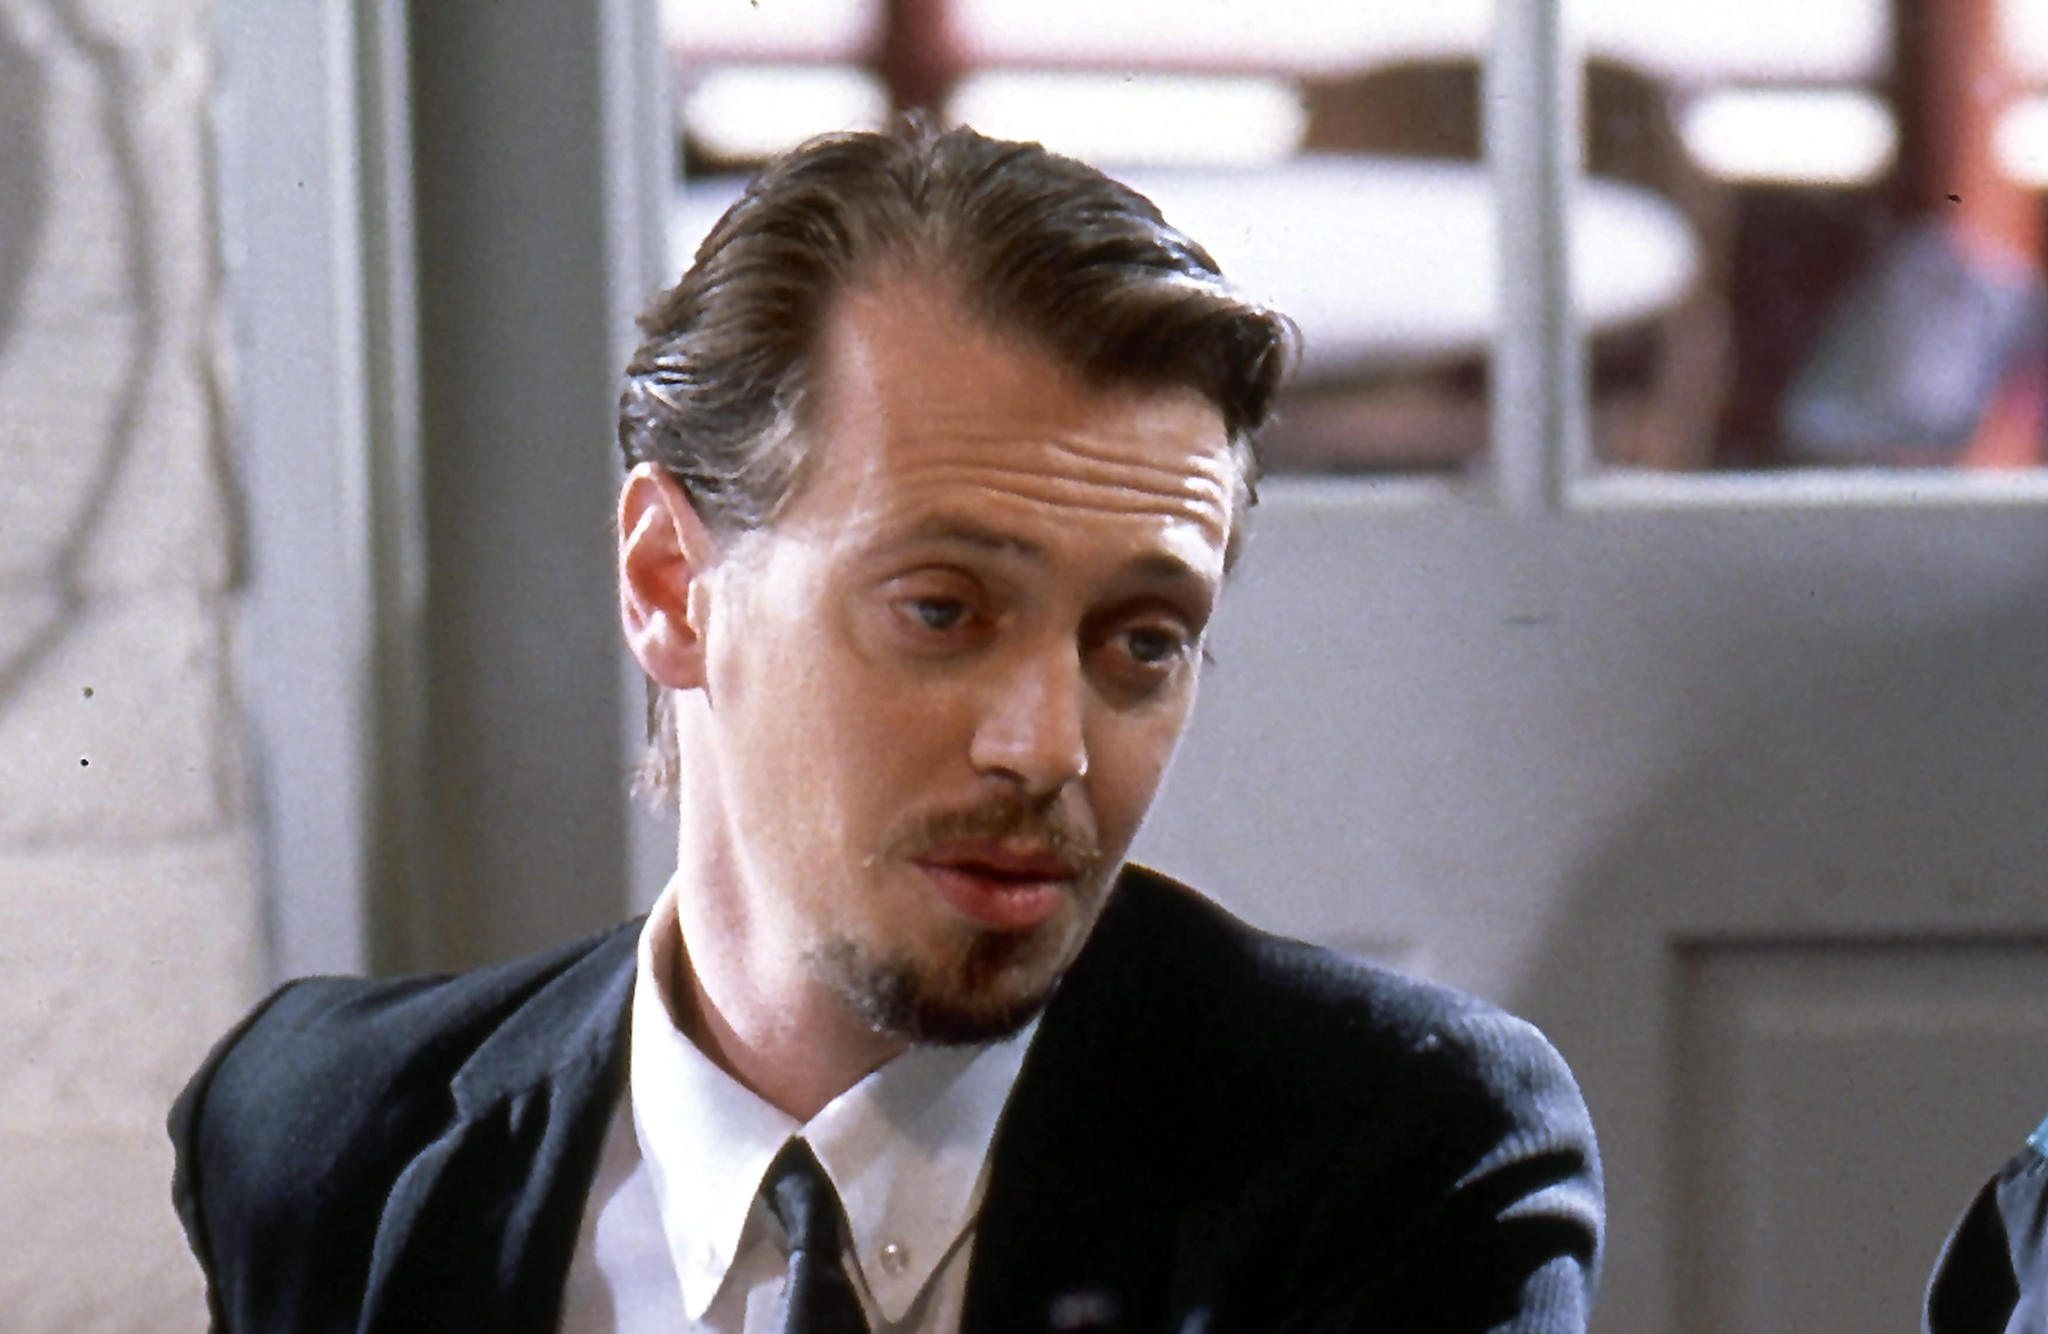What kind of relationship do you infer between the character and his surroundings? The character, Mr. Pink, seems to have a complex relationship with his surroundings. The formal attire juxtaposed with what appears to be a casual setting of a restaurant or cafe suggests a man out of place, highlighting a sense of disconnection or dissonance. This could symbolize the divided nature of his life, caught between the worlds of crime and ordinary existence. The slightly blurred background adds to this notion, implying that while he is physically present in the space, his mind is elsewhere, entangled in thoughts and dilemmas far removed from the present setting. Expand on this interpretation with more details. Mr. Pink's disconnection from the setting can be further interpreted by analyzing his attire and expression. The black suit and tie are symbols of formality and control, often associated with business or serious matters. In contrast, casual dining spaces are usually meant for relaxation and leisure, yet Mr. Pink doesn't appear to be at ease. His body language and facial expression suggest tension and preoccupation. This stark contrast may underscore his dual life—participating in criminal activities while trying to blend into normal society. The blurred background could metaphorically represent the haziness of his moral judgments or the uncertainty of his current situation. 